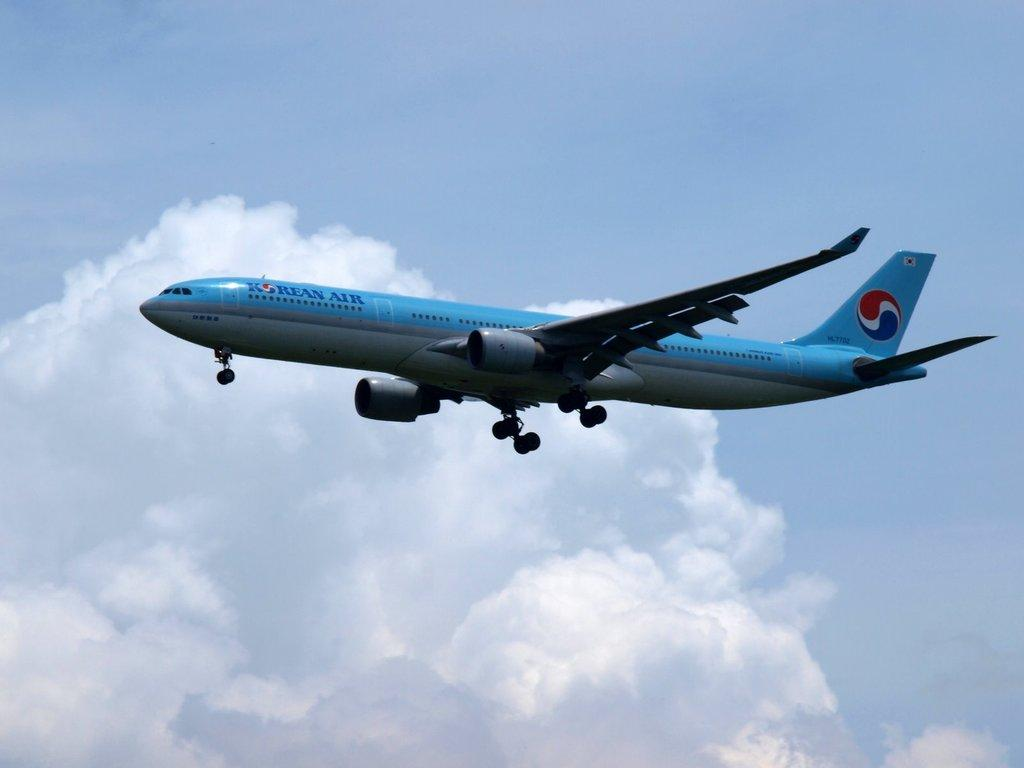<image>
Relay a brief, clear account of the picture shown. An airplane with the words Korean Air on it flying near a cloud. 